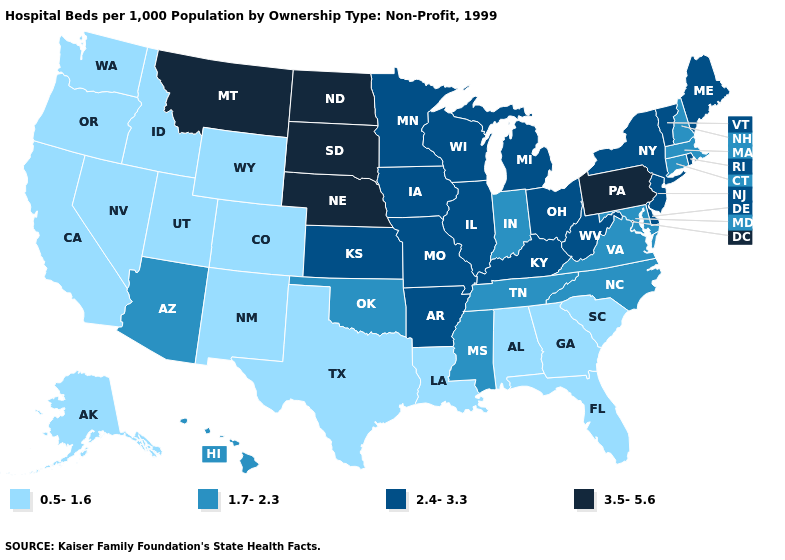What is the lowest value in states that border California?
Write a very short answer. 0.5-1.6. Name the states that have a value in the range 1.7-2.3?
Answer briefly. Arizona, Connecticut, Hawaii, Indiana, Maryland, Massachusetts, Mississippi, New Hampshire, North Carolina, Oklahoma, Tennessee, Virginia. Name the states that have a value in the range 0.5-1.6?
Short answer required. Alabama, Alaska, California, Colorado, Florida, Georgia, Idaho, Louisiana, Nevada, New Mexico, Oregon, South Carolina, Texas, Utah, Washington, Wyoming. Name the states that have a value in the range 2.4-3.3?
Be succinct. Arkansas, Delaware, Illinois, Iowa, Kansas, Kentucky, Maine, Michigan, Minnesota, Missouri, New Jersey, New York, Ohio, Rhode Island, Vermont, West Virginia, Wisconsin. Name the states that have a value in the range 2.4-3.3?
Write a very short answer. Arkansas, Delaware, Illinois, Iowa, Kansas, Kentucky, Maine, Michigan, Minnesota, Missouri, New Jersey, New York, Ohio, Rhode Island, Vermont, West Virginia, Wisconsin. Does Louisiana have a higher value than New Hampshire?
Concise answer only. No. Is the legend a continuous bar?
Quick response, please. No. Does New Jersey have the lowest value in the Northeast?
Short answer required. No. Among the states that border Alabama , does Tennessee have the highest value?
Keep it brief. Yes. Name the states that have a value in the range 2.4-3.3?
Answer briefly. Arkansas, Delaware, Illinois, Iowa, Kansas, Kentucky, Maine, Michigan, Minnesota, Missouri, New Jersey, New York, Ohio, Rhode Island, Vermont, West Virginia, Wisconsin. What is the value of New York?
Keep it brief. 2.4-3.3. Name the states that have a value in the range 1.7-2.3?
Write a very short answer. Arizona, Connecticut, Hawaii, Indiana, Maryland, Massachusetts, Mississippi, New Hampshire, North Carolina, Oklahoma, Tennessee, Virginia. What is the value of Arizona?
Write a very short answer. 1.7-2.3. Which states have the lowest value in the USA?
Quick response, please. Alabama, Alaska, California, Colorado, Florida, Georgia, Idaho, Louisiana, Nevada, New Mexico, Oregon, South Carolina, Texas, Utah, Washington, Wyoming. What is the value of Oregon?
Answer briefly. 0.5-1.6. 